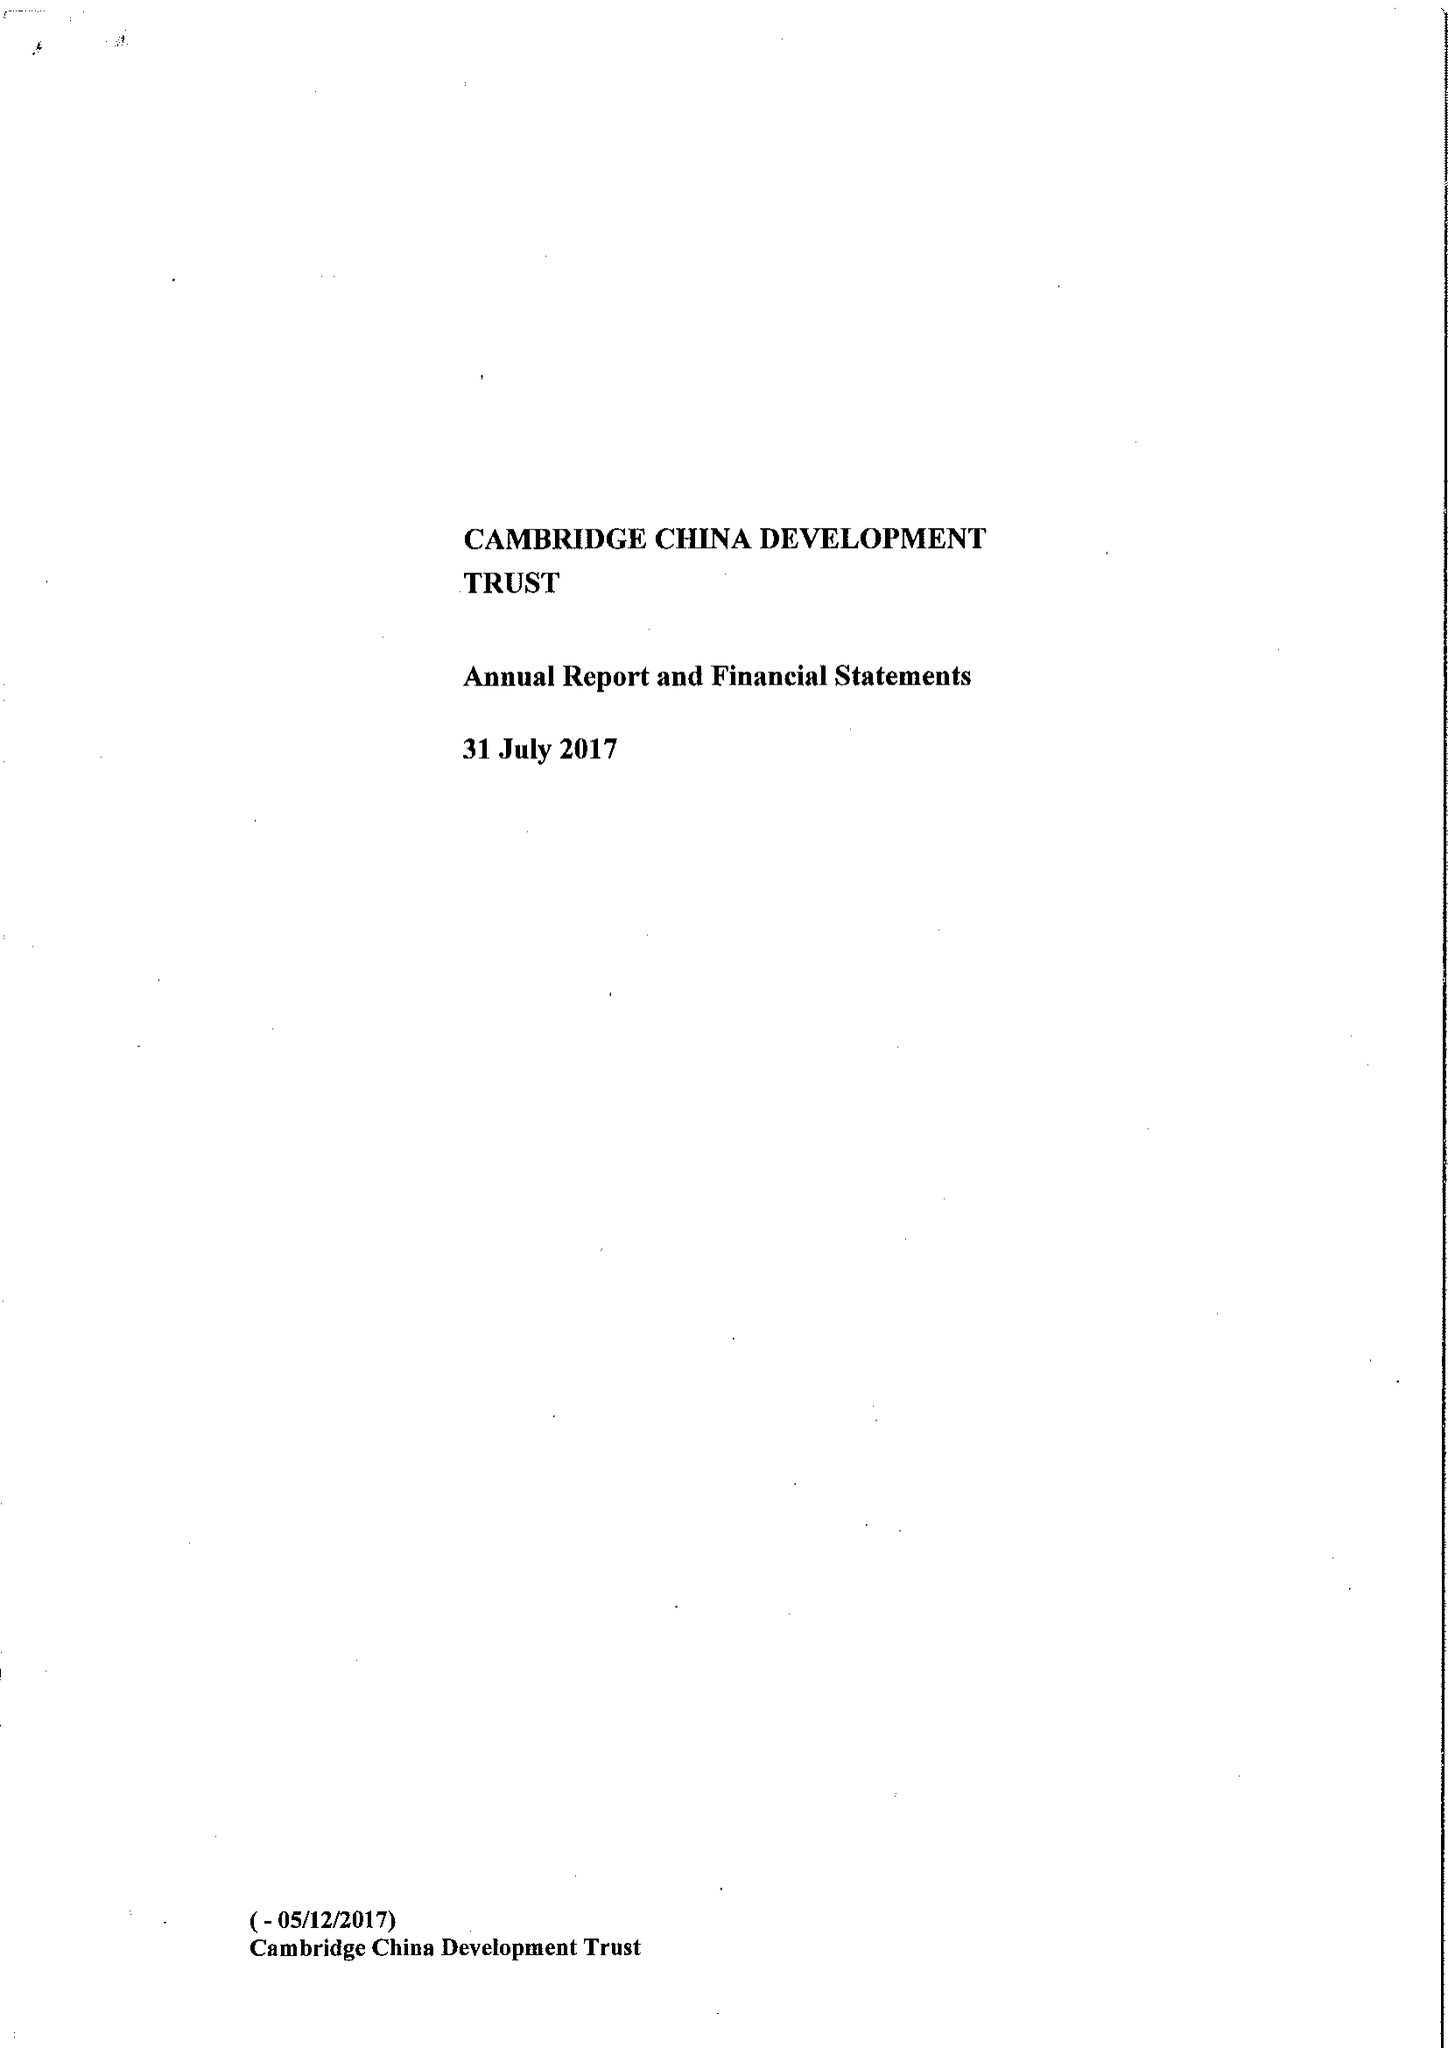What is the value for the charity_number?
Answer the question using a single word or phrase. 1111605 